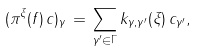<formula> <loc_0><loc_0><loc_500><loc_500>( \pi ^ { \xi } ( f ) \, c ) _ { \gamma } \, = \, \sum _ { \gamma ^ { \prime } \in \Gamma } k _ { \gamma , \gamma ^ { \prime } } ( \xi ) \, c _ { \gamma ^ { \prime } } ,</formula> 